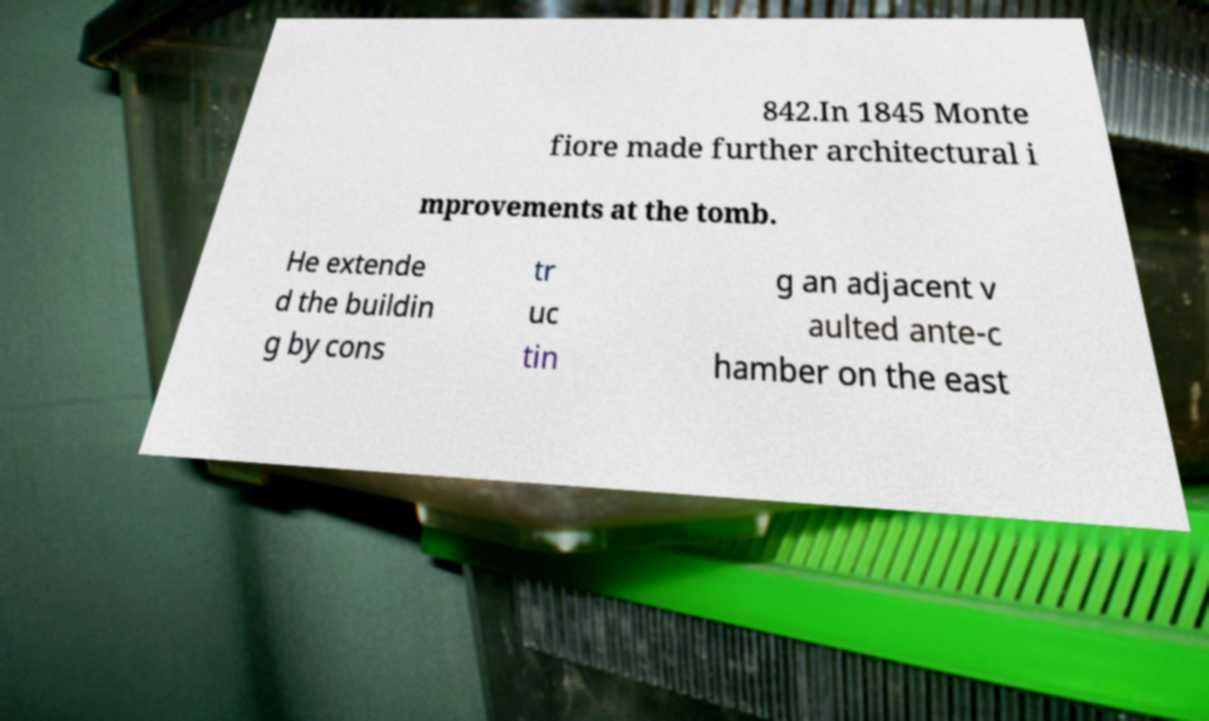For documentation purposes, I need the text within this image transcribed. Could you provide that? 842.In 1845 Monte fiore made further architectural i mprovements at the tomb. He extende d the buildin g by cons tr uc tin g an adjacent v aulted ante-c hamber on the east 